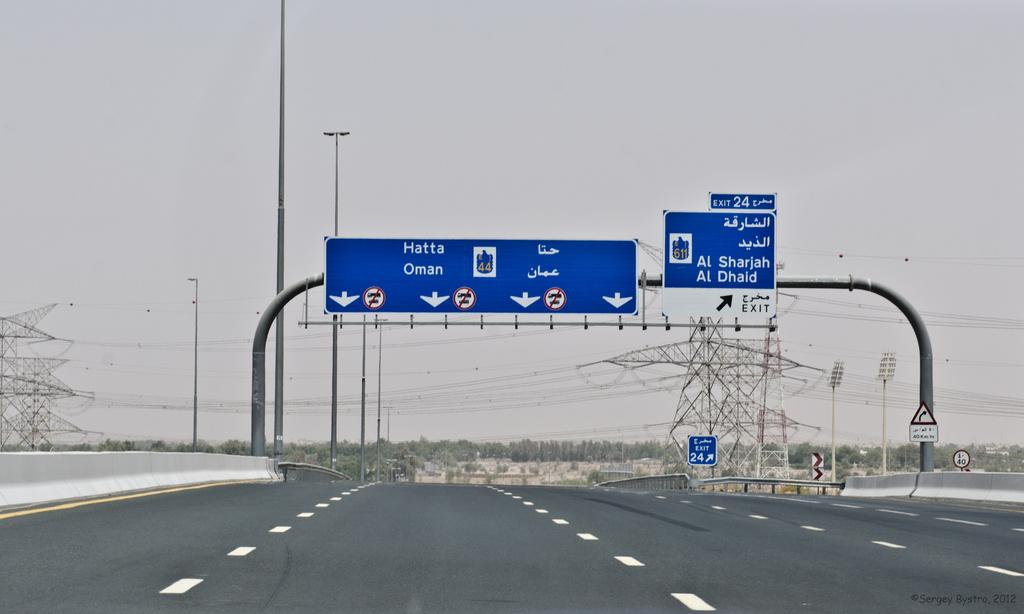Provide a one-sentence caption for the provided image. street signs on where to go for Hatta Oman. 